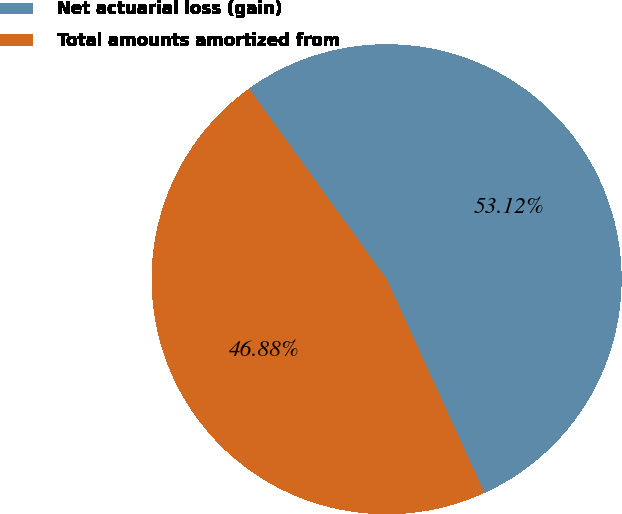Convert chart to OTSL. <chart><loc_0><loc_0><loc_500><loc_500><pie_chart><fcel>Net actuarial loss (gain)<fcel>Total amounts amortized from<nl><fcel>53.12%<fcel>46.88%<nl></chart> 